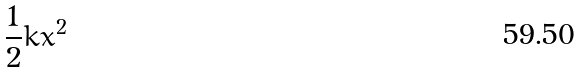<formula> <loc_0><loc_0><loc_500><loc_500>\frac { 1 } { 2 } k x ^ { 2 }</formula> 